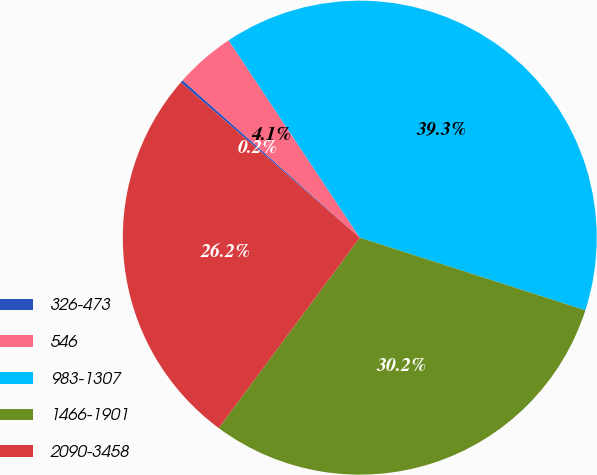Convert chart to OTSL. <chart><loc_0><loc_0><loc_500><loc_500><pie_chart><fcel>326-473<fcel>546<fcel>983-1307<fcel>1466-1901<fcel>2090-3458<nl><fcel>0.19%<fcel>4.1%<fcel>39.3%<fcel>30.19%<fcel>26.23%<nl></chart> 